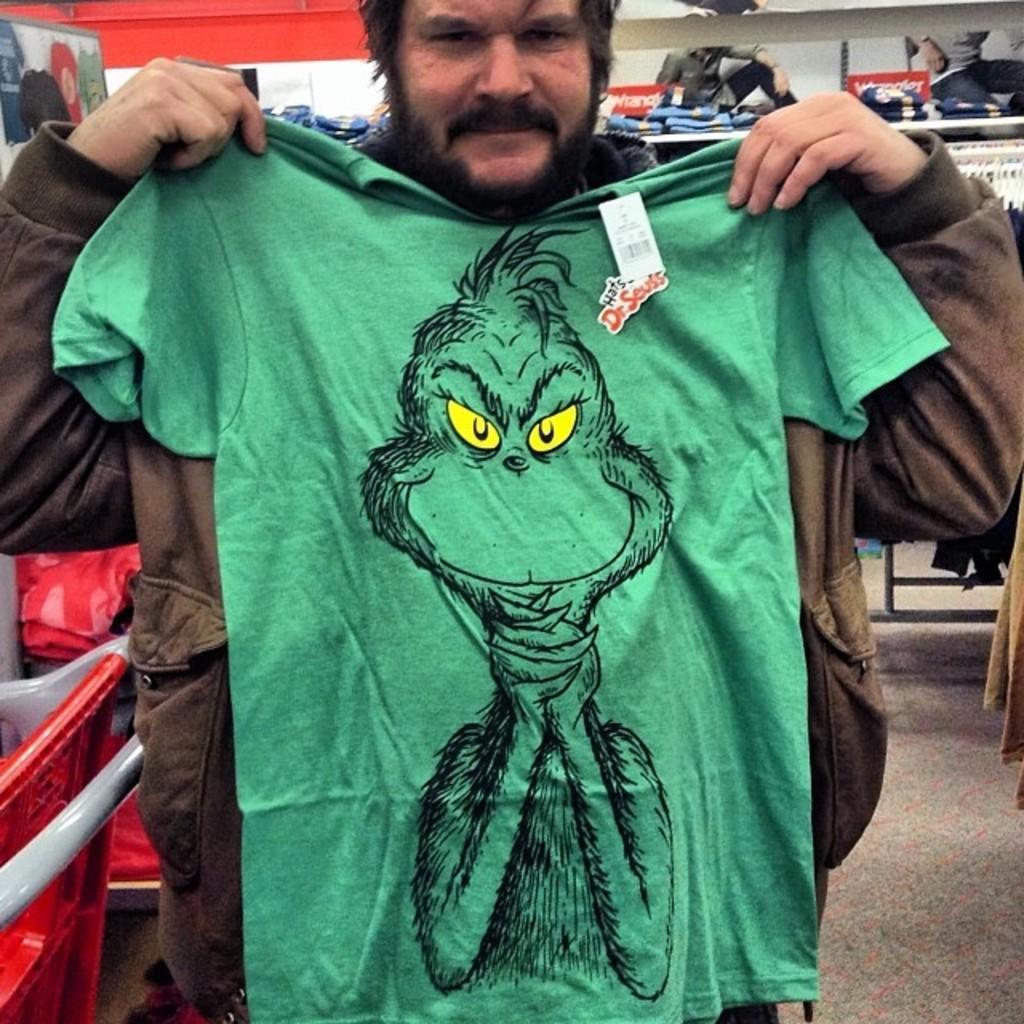How would you summarize this image in a sentence or two? There is a man standing and holding a t shirt,beside him we can see red object and rod. In the background we can see clothes in racks,clothes hanging on stand,wall,floor and posters. 